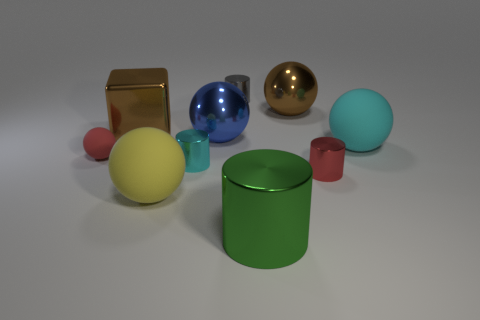How many other things are there of the same size as the yellow sphere?
Your answer should be very brief. 5. There is a matte object that is behind the tiny cyan metallic cylinder and left of the large cyan ball; what is its size?
Offer a terse response. Small. How many other tiny metal things have the same shape as the green metal thing?
Ensure brevity in your answer.  3. What is the small cyan cylinder made of?
Your answer should be very brief. Metal. Do the tiny red shiny thing and the gray metal thing have the same shape?
Offer a terse response. Yes. Are there any brown objects that have the same material as the small gray thing?
Give a very brief answer. Yes. The shiny thing that is both left of the tiny gray shiny object and in front of the large cyan rubber object is what color?
Make the answer very short. Cyan. What is the material of the cyan thing in front of the small matte object?
Make the answer very short. Metal. Is there a tiny yellow thing that has the same shape as the blue thing?
Your response must be concise. No. What number of other things are there of the same shape as the large cyan thing?
Keep it short and to the point. 4. 